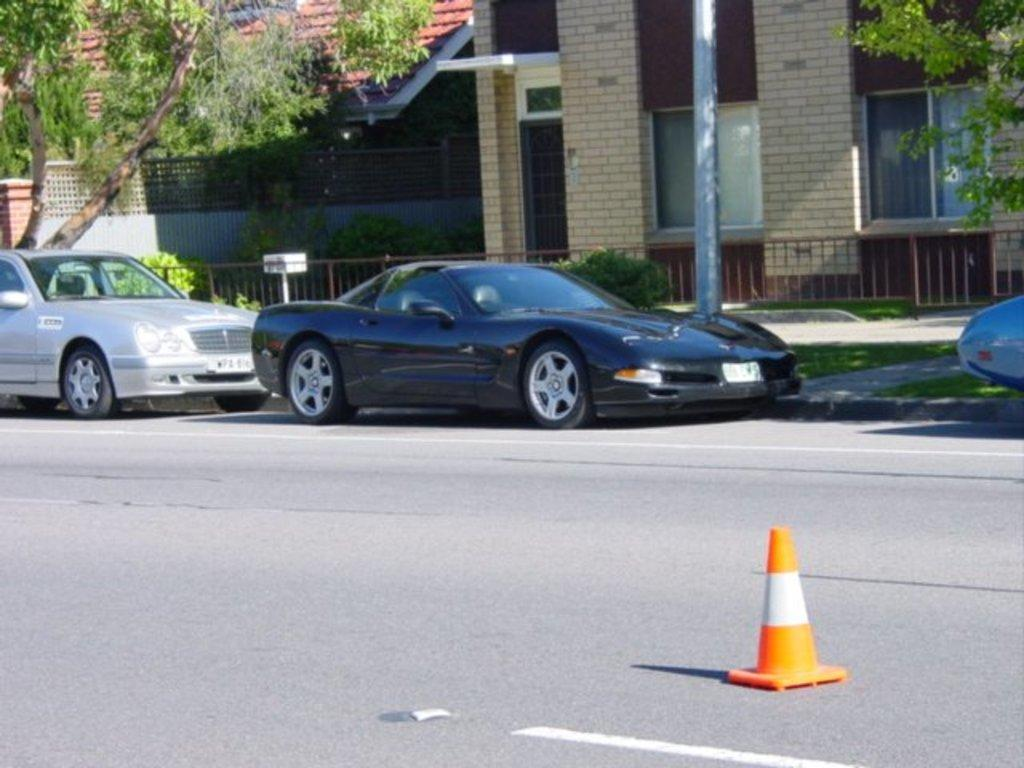What can be seen on the road in the image? There are cars on the road in the image. What type of cup is present in the image? There is a traffic cone cup in the image. What type of barrier is visible in the image? There is a metal fence in the image. What is the tall, vertical object in the image? There is a pole in the image. What can be seen in the distance in the image? There are buildings and trees in the background of the image. What type of ornament is hanging from the pole in the image? There is no ornament hanging from the pole in the image; only a traffic cone cup and cars are present. How many bulbs are visible in the image? There are no bulbs visible in the image. 